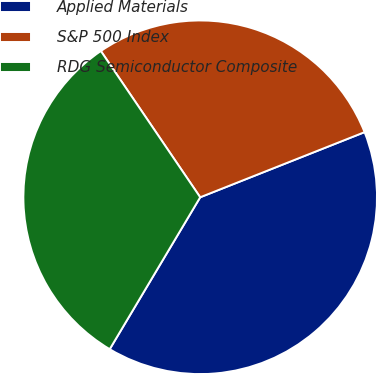Convert chart to OTSL. <chart><loc_0><loc_0><loc_500><loc_500><pie_chart><fcel>Applied Materials<fcel>S&P 500 Index<fcel>RDG Semiconductor Composite<nl><fcel>39.55%<fcel>28.49%<fcel>31.95%<nl></chart> 